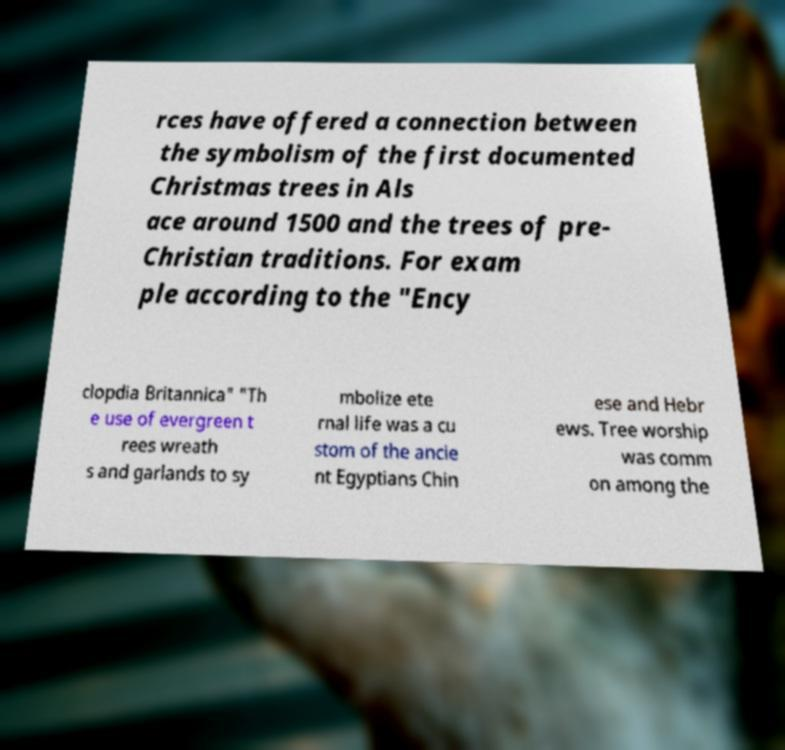I need the written content from this picture converted into text. Can you do that? rces have offered a connection between the symbolism of the first documented Christmas trees in Als ace around 1500 and the trees of pre- Christian traditions. For exam ple according to the "Ency clopdia Britannica" "Th e use of evergreen t rees wreath s and garlands to sy mbolize ete rnal life was a cu stom of the ancie nt Egyptians Chin ese and Hebr ews. Tree worship was comm on among the 